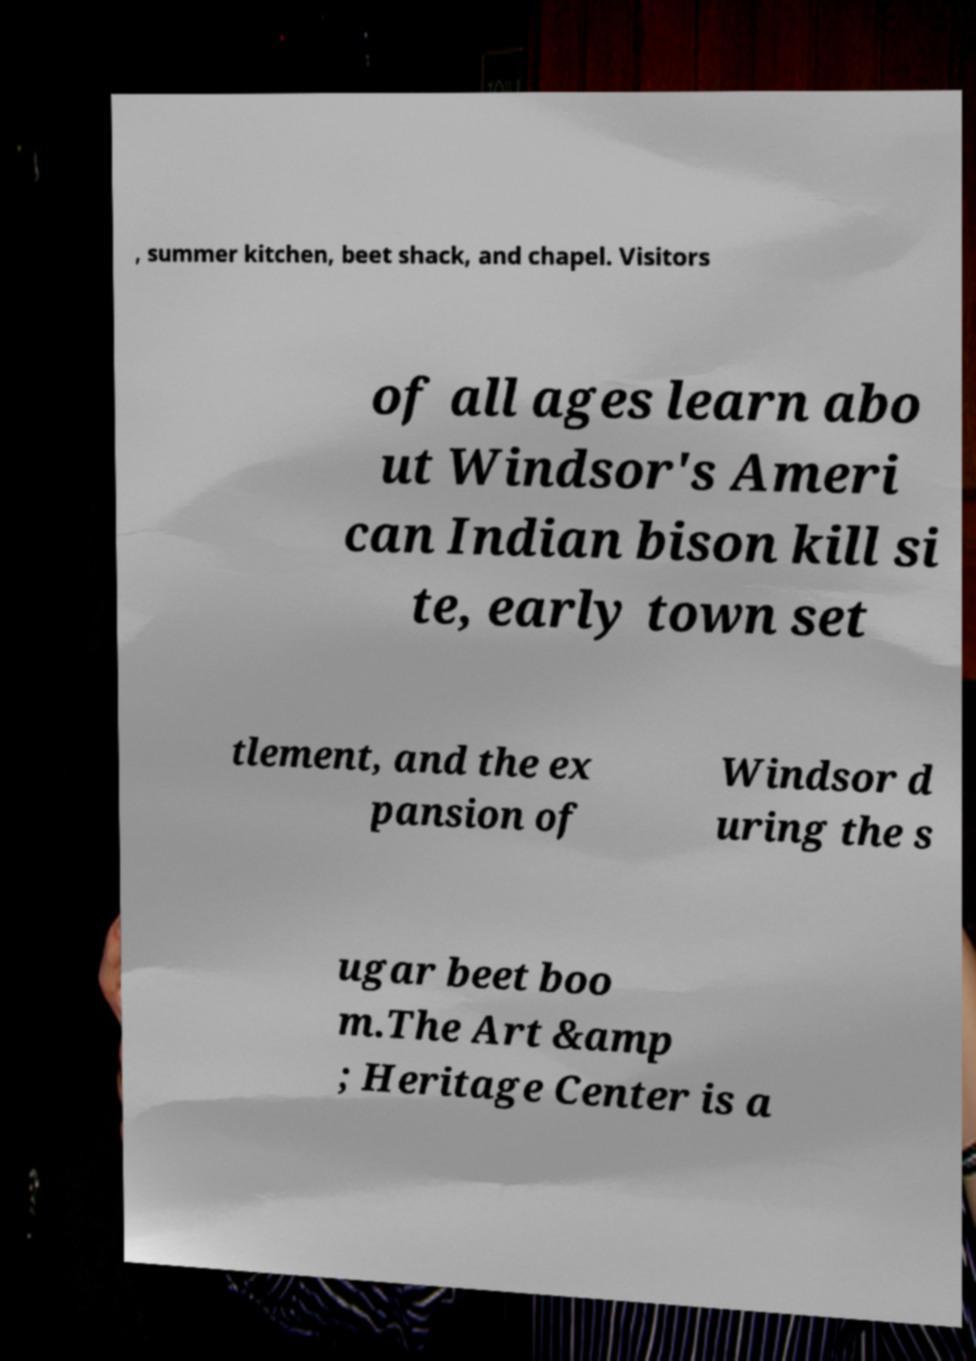Can you accurately transcribe the text from the provided image for me? , summer kitchen, beet shack, and chapel. Visitors of all ages learn abo ut Windsor's Ameri can Indian bison kill si te, early town set tlement, and the ex pansion of Windsor d uring the s ugar beet boo m.The Art &amp ; Heritage Center is a 